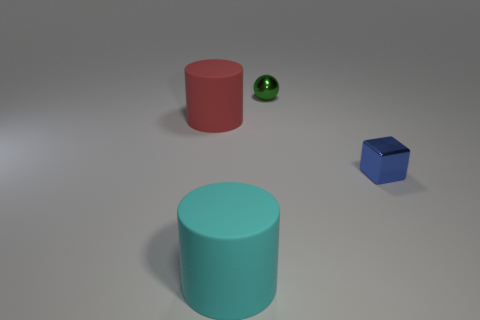Add 4 red cubes. How many objects exist? 8 Subtract all cubes. How many objects are left? 3 Subtract 0 gray cubes. How many objects are left? 4 Subtract all tiny red rubber balls. Subtract all cylinders. How many objects are left? 2 Add 2 metallic balls. How many metallic balls are left? 3 Add 3 tiny shiny things. How many tiny shiny things exist? 5 